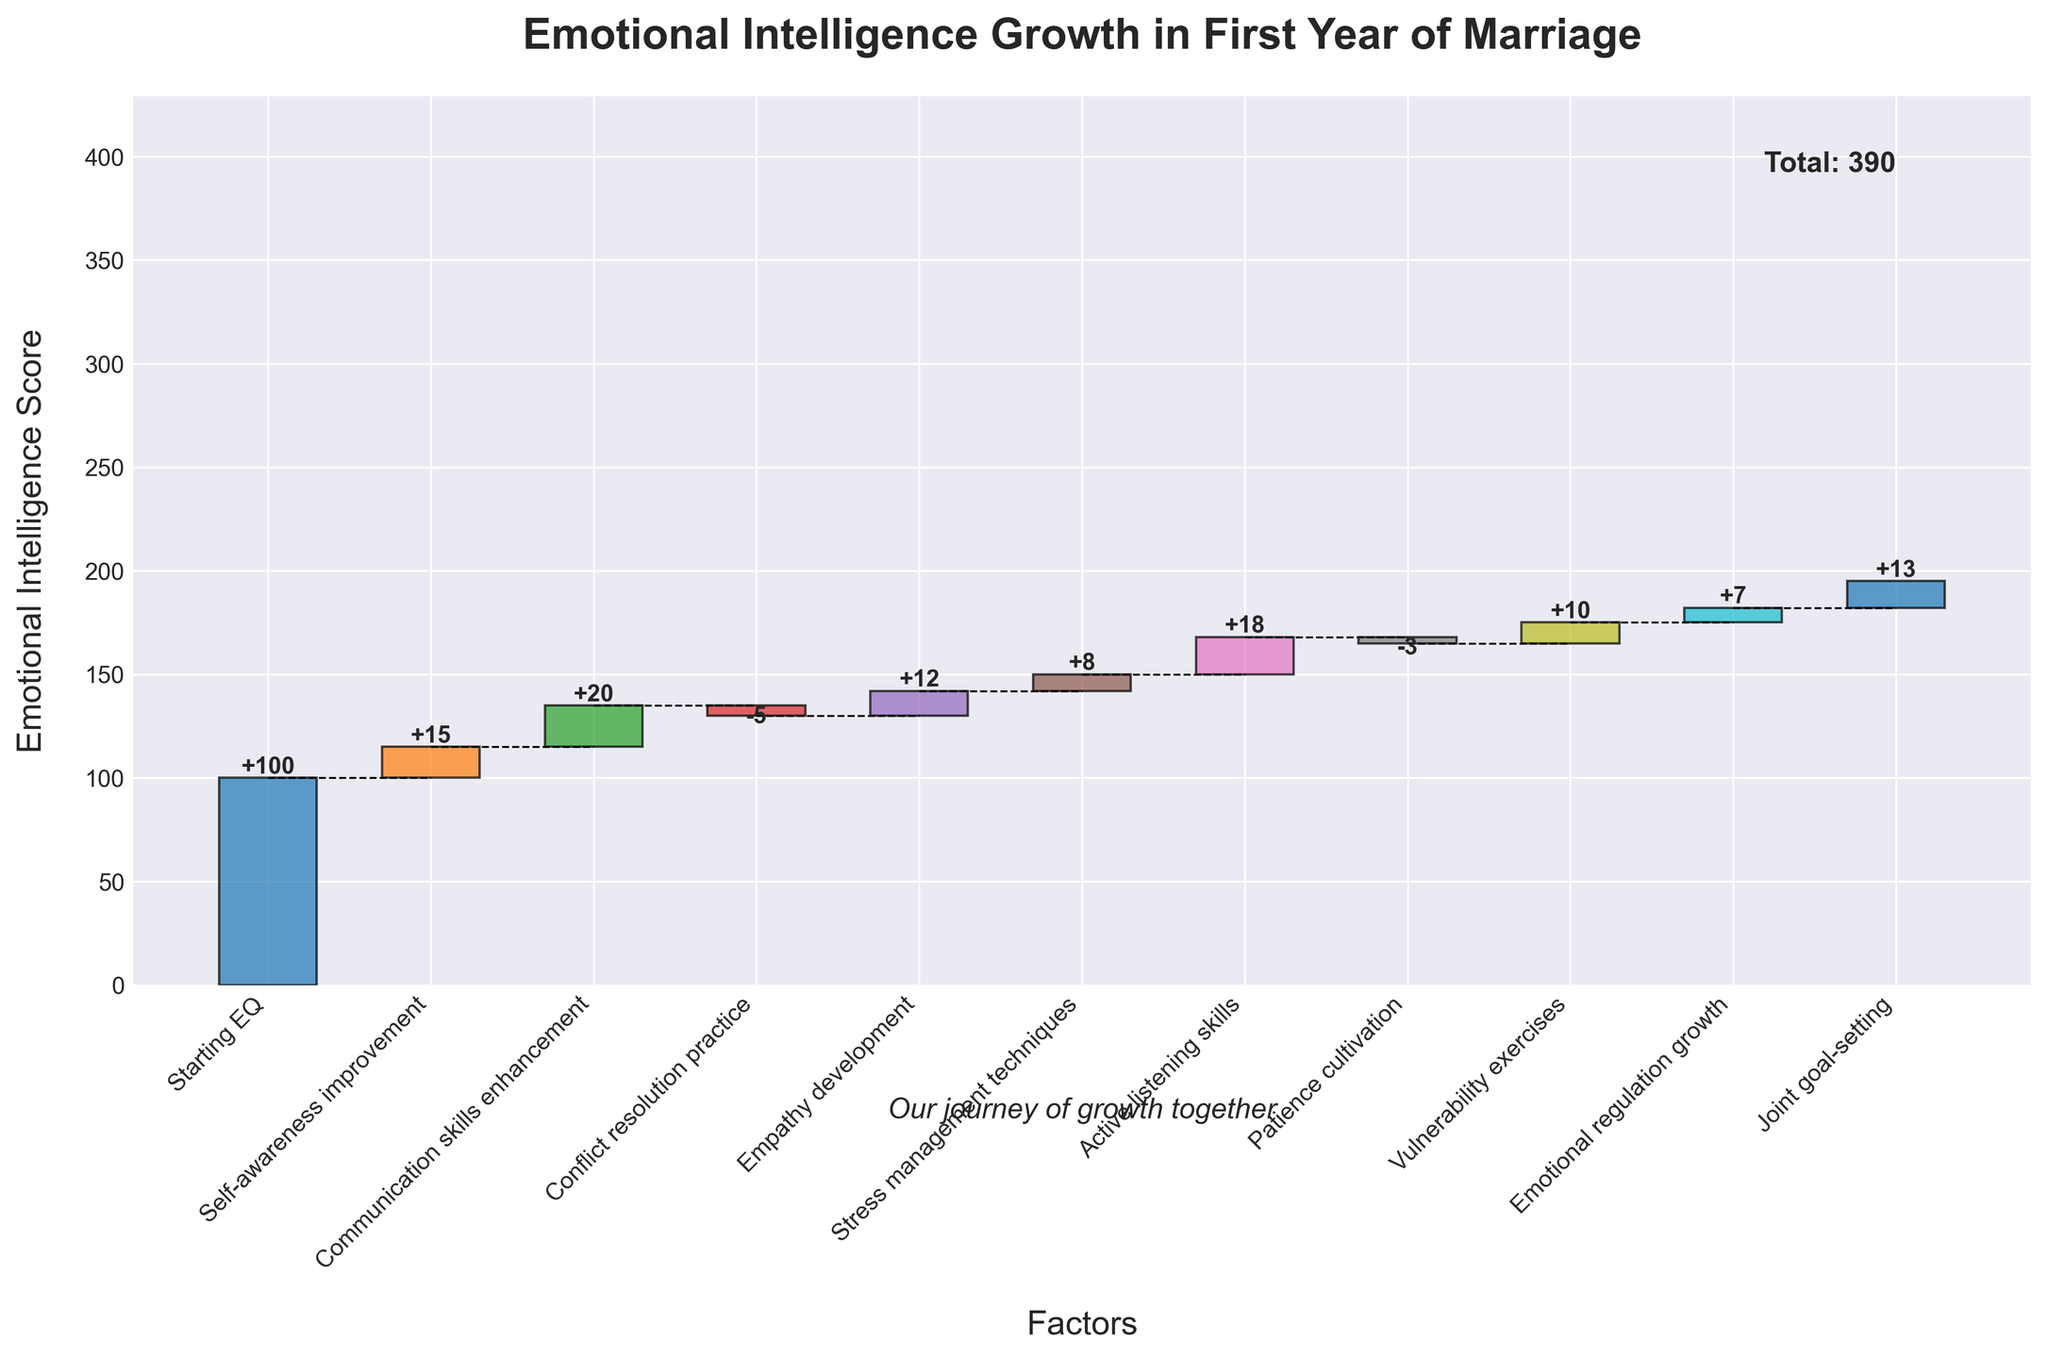What is the title of the chart? The title of the chart is located at the top and is a single phrase summarizing the data being visualized.
Answer: Emotional Intelligence Growth in First Year of Marriage Which factor contributed the most positive change in Emotional Intelligence? By observing the height of the bars, the highest positive bar represents the factor with the most positive change.
Answer: Communication skills enhancement How did conflict resolution practice impact the Emotional Intelligence score? By looking at the direction and color of the bar corresponding to "Conflict resolution practice," we can determine if it had a positive or negative impact.
Answer: -5 What is the total increase in the Emotional Intelligence score from starting EQ to ending EQ? The total increase is calculated by subtracting the starting EQ value from the ending EQ value. Starting EQ is 100, and Ending EQ is 195, so 195 - 100 = 95.
Answer: 95 How did patience cultivation impact the Emotional Intelligence score? By observing the direction and numerical value associated with the "Patience cultivation" bar, we determine its impact.
Answer: -3 Which factors had a negative impact on the Emotional Intelligence score? By identifying bars that go downward or have negative values, we find the factors with a negative impact. The bars corresponding to "Conflict resolution practice" and "Patience cultivation" go downward.
Answer: Conflict resolution practice, Patience cultivation How many factors contributed positively to the Emotional Intelligence score? By counting the bars that represent positive changes in the chart, we determine the number of factors that contributed positively.
Answer: 8 Which had a greater positive impact: Emotional regulation growth or Joint goal-setting? By comparing the heights and values of the bars for "Emotional regulation growth" and "Joint goal-setting," we determine the greater positive impact. "Joint goal-setting" has a value of 13, while "Emotional regulation growth" has a value of 7.
Answer: Joint goal-setting What is the cumulative score after adding active listening skills? To find this, we need to sum the initial value and the positive/negative changes up to and including active listening skills. Starting EQ (100) + Self-awareness improvement (+15) + Communication skills enhancement (+20) + Conflict resolution practice (-5) + Empathy development (+12) + Stress management techniques (+8) + Active listening skills (+18) = 168
Answer: 168 What is the overall Emotional Intelligence score after adding or subtracting each contributing factor? To find this, we need to sum the initial value and all the subsequent values. Starting EQ (100) + Self-awareness improvement (+15) + Communication skills enhancement (+20) + Conflict resolution practice (-5) + Empathy development (+12) + Stress management techniques (+8) + Active listening skills (+18) + Patience cultivation (-3) + Vulnerability exercises (+10) + Emotional regulation growth (+7) + Joint goal-setting (+13) = 195
Answer: 195 